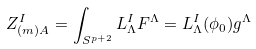<formula> <loc_0><loc_0><loc_500><loc_500>Z _ { ( m ) A } ^ { I } = \int _ { S ^ { p + 2 } } L _ { \Lambda } ^ { I } F ^ { \Lambda } = L _ { \Lambda } ^ { I } ( \phi _ { 0 } ) g ^ { \Lambda }</formula> 